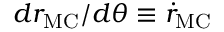<formula> <loc_0><loc_0><loc_500><loc_500>{ { d r _ { M C } } / { d \theta } } \equiv \dot { r } _ { M C }</formula> 